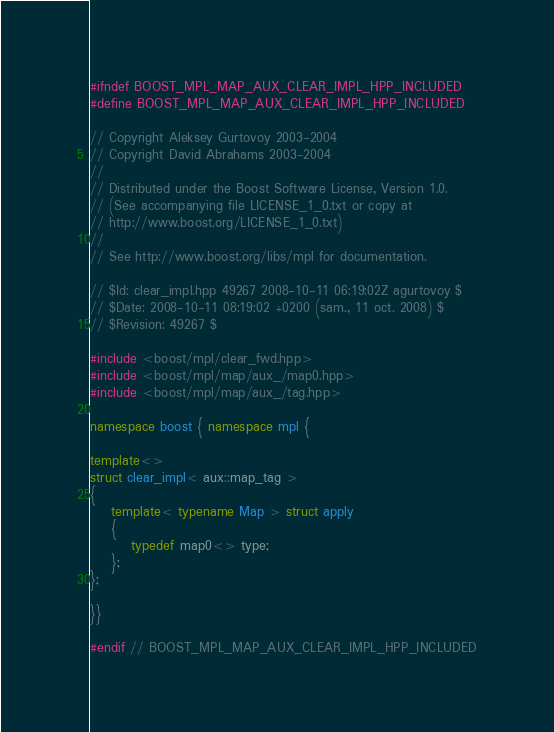<code> <loc_0><loc_0><loc_500><loc_500><_C++_>
#ifndef BOOST_MPL_MAP_AUX_CLEAR_IMPL_HPP_INCLUDED
#define BOOST_MPL_MAP_AUX_CLEAR_IMPL_HPP_INCLUDED

// Copyright Aleksey Gurtovoy 2003-2004
// Copyright David Abrahams 2003-2004
//
// Distributed under the Boost Software License, Version 1.0. 
// (See accompanying file LICENSE_1_0.txt or copy at 
// http://www.boost.org/LICENSE_1_0.txt)
//
// See http://www.boost.org/libs/mpl for documentation.

// $Id: clear_impl.hpp 49267 2008-10-11 06:19:02Z agurtovoy $
// $Date: 2008-10-11 08:19:02 +0200 (sam., 11 oct. 2008) $
// $Revision: 49267 $

#include <boost/mpl/clear_fwd.hpp>
#include <boost/mpl/map/aux_/map0.hpp>
#include <boost/mpl/map/aux_/tag.hpp>

namespace boost { namespace mpl {

template<>
struct clear_impl< aux::map_tag >
{
    template< typename Map > struct apply
    {
        typedef map0<> type;
    };
};

}}

#endif // BOOST_MPL_MAP_AUX_CLEAR_IMPL_HPP_INCLUDED
</code> 